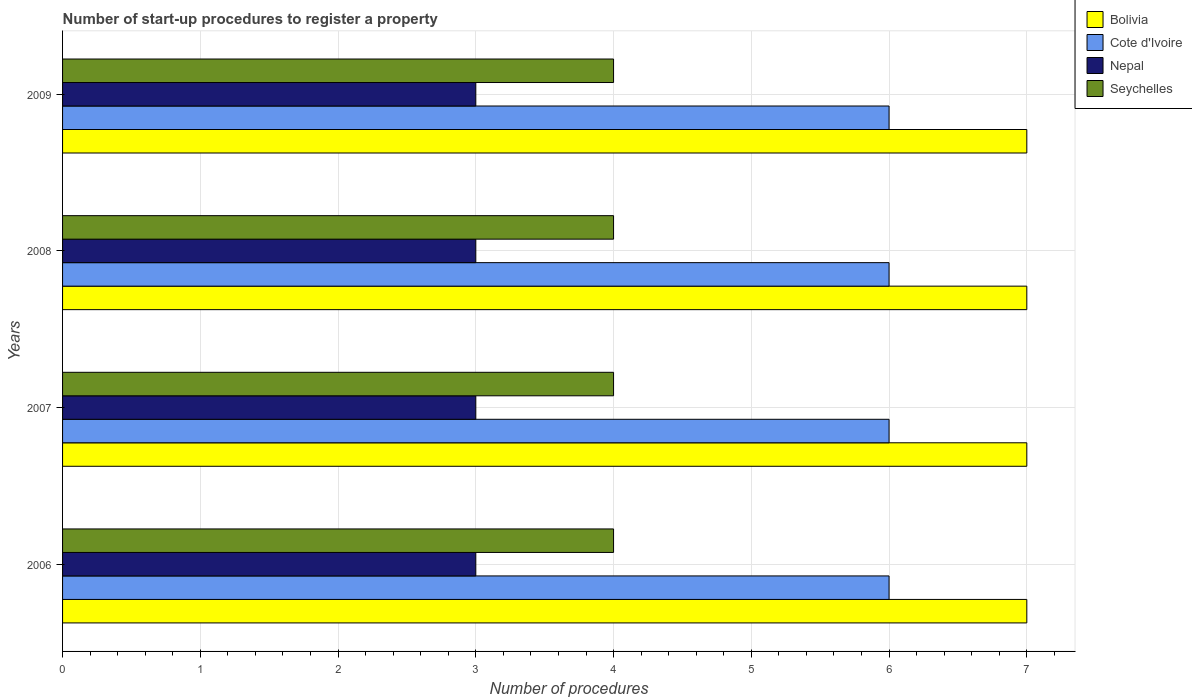How many different coloured bars are there?
Your response must be concise. 4. How many bars are there on the 1st tick from the top?
Offer a terse response. 4. How many bars are there on the 3rd tick from the bottom?
Your response must be concise. 4. In how many cases, is the number of bars for a given year not equal to the number of legend labels?
Your answer should be compact. 0. What is the number of procedures required to register a property in Nepal in 2008?
Ensure brevity in your answer.  3. Across all years, what is the maximum number of procedures required to register a property in Cote d'Ivoire?
Your answer should be very brief. 6. Across all years, what is the minimum number of procedures required to register a property in Nepal?
Your answer should be compact. 3. In which year was the number of procedures required to register a property in Seychelles minimum?
Make the answer very short. 2006. What is the total number of procedures required to register a property in Nepal in the graph?
Your answer should be very brief. 12. What is the difference between the number of procedures required to register a property in Cote d'Ivoire in 2006 and that in 2009?
Give a very brief answer. 0. What is the average number of procedures required to register a property in Cote d'Ivoire per year?
Provide a succinct answer. 6. In the year 2009, what is the difference between the number of procedures required to register a property in Cote d'Ivoire and number of procedures required to register a property in Bolivia?
Offer a very short reply. -1. What is the ratio of the number of procedures required to register a property in Seychelles in 2007 to that in 2009?
Your answer should be compact. 1. Is the number of procedures required to register a property in Seychelles in 2007 less than that in 2008?
Make the answer very short. No. In how many years, is the number of procedures required to register a property in Nepal greater than the average number of procedures required to register a property in Nepal taken over all years?
Offer a very short reply. 0. Is the sum of the number of procedures required to register a property in Nepal in 2006 and 2009 greater than the maximum number of procedures required to register a property in Seychelles across all years?
Give a very brief answer. Yes. Is it the case that in every year, the sum of the number of procedures required to register a property in Bolivia and number of procedures required to register a property in Nepal is greater than the sum of number of procedures required to register a property in Cote d'Ivoire and number of procedures required to register a property in Seychelles?
Keep it short and to the point. No. What does the 2nd bar from the top in 2006 represents?
Give a very brief answer. Nepal. What does the 2nd bar from the bottom in 2009 represents?
Keep it short and to the point. Cote d'Ivoire. Is it the case that in every year, the sum of the number of procedures required to register a property in Nepal and number of procedures required to register a property in Seychelles is greater than the number of procedures required to register a property in Cote d'Ivoire?
Provide a succinct answer. Yes. Are all the bars in the graph horizontal?
Give a very brief answer. Yes. How many years are there in the graph?
Your response must be concise. 4. Does the graph contain any zero values?
Offer a very short reply. No. How many legend labels are there?
Offer a terse response. 4. What is the title of the graph?
Your answer should be very brief. Number of start-up procedures to register a property. Does "Turkmenistan" appear as one of the legend labels in the graph?
Your response must be concise. No. What is the label or title of the X-axis?
Keep it short and to the point. Number of procedures. What is the Number of procedures in Bolivia in 2006?
Offer a very short reply. 7. What is the Number of procedures in Nepal in 2006?
Give a very brief answer. 3. What is the Number of procedures of Nepal in 2007?
Offer a very short reply. 3. What is the Number of procedures of Bolivia in 2008?
Your answer should be compact. 7. What is the Number of procedures of Seychelles in 2008?
Offer a very short reply. 4. Across all years, what is the maximum Number of procedures of Cote d'Ivoire?
Your answer should be very brief. 6. Across all years, what is the maximum Number of procedures in Nepal?
Your response must be concise. 3. Across all years, what is the maximum Number of procedures of Seychelles?
Offer a very short reply. 4. Across all years, what is the minimum Number of procedures of Nepal?
Provide a succinct answer. 3. Across all years, what is the minimum Number of procedures of Seychelles?
Your answer should be compact. 4. What is the total Number of procedures in Nepal in the graph?
Provide a succinct answer. 12. What is the difference between the Number of procedures in Bolivia in 2006 and that in 2007?
Provide a succinct answer. 0. What is the difference between the Number of procedures of Cote d'Ivoire in 2006 and that in 2007?
Your response must be concise. 0. What is the difference between the Number of procedures of Seychelles in 2006 and that in 2008?
Give a very brief answer. 0. What is the difference between the Number of procedures of Bolivia in 2006 and that in 2009?
Offer a terse response. 0. What is the difference between the Number of procedures in Cote d'Ivoire in 2007 and that in 2008?
Make the answer very short. 0. What is the difference between the Number of procedures of Nepal in 2007 and that in 2008?
Your response must be concise. 0. What is the difference between the Number of procedures in Seychelles in 2007 and that in 2008?
Give a very brief answer. 0. What is the difference between the Number of procedures in Bolivia in 2007 and that in 2009?
Your response must be concise. 0. What is the difference between the Number of procedures in Cote d'Ivoire in 2007 and that in 2009?
Make the answer very short. 0. What is the difference between the Number of procedures of Nepal in 2007 and that in 2009?
Keep it short and to the point. 0. What is the difference between the Number of procedures of Bolivia in 2008 and that in 2009?
Your answer should be compact. 0. What is the difference between the Number of procedures of Cote d'Ivoire in 2008 and that in 2009?
Provide a short and direct response. 0. What is the difference between the Number of procedures of Nepal in 2008 and that in 2009?
Ensure brevity in your answer.  0. What is the difference between the Number of procedures of Seychelles in 2008 and that in 2009?
Offer a terse response. 0. What is the difference between the Number of procedures in Bolivia in 2006 and the Number of procedures in Nepal in 2007?
Your answer should be very brief. 4. What is the difference between the Number of procedures of Cote d'Ivoire in 2006 and the Number of procedures of Nepal in 2007?
Make the answer very short. 3. What is the difference between the Number of procedures in Cote d'Ivoire in 2006 and the Number of procedures in Seychelles in 2007?
Offer a terse response. 2. What is the difference between the Number of procedures of Cote d'Ivoire in 2006 and the Number of procedures of Nepal in 2008?
Ensure brevity in your answer.  3. What is the difference between the Number of procedures of Bolivia in 2006 and the Number of procedures of Cote d'Ivoire in 2009?
Keep it short and to the point. 1. What is the difference between the Number of procedures in Bolivia in 2006 and the Number of procedures in Nepal in 2009?
Provide a succinct answer. 4. What is the difference between the Number of procedures in Bolivia in 2007 and the Number of procedures in Cote d'Ivoire in 2008?
Offer a terse response. 1. What is the difference between the Number of procedures in Bolivia in 2007 and the Number of procedures in Nepal in 2008?
Your response must be concise. 4. What is the difference between the Number of procedures in Bolivia in 2007 and the Number of procedures in Seychelles in 2008?
Keep it short and to the point. 3. What is the difference between the Number of procedures of Nepal in 2007 and the Number of procedures of Seychelles in 2008?
Provide a short and direct response. -1. What is the difference between the Number of procedures in Bolivia in 2007 and the Number of procedures in Cote d'Ivoire in 2009?
Offer a very short reply. 1. What is the difference between the Number of procedures in Bolivia in 2007 and the Number of procedures in Seychelles in 2009?
Offer a very short reply. 3. What is the difference between the Number of procedures in Bolivia in 2008 and the Number of procedures in Seychelles in 2009?
Offer a very short reply. 3. What is the difference between the Number of procedures of Cote d'Ivoire in 2008 and the Number of procedures of Nepal in 2009?
Your answer should be very brief. 3. What is the difference between the Number of procedures in Cote d'Ivoire in 2008 and the Number of procedures in Seychelles in 2009?
Ensure brevity in your answer.  2. What is the difference between the Number of procedures in Nepal in 2008 and the Number of procedures in Seychelles in 2009?
Your answer should be compact. -1. What is the average Number of procedures of Cote d'Ivoire per year?
Make the answer very short. 6. What is the average Number of procedures of Nepal per year?
Offer a very short reply. 3. In the year 2006, what is the difference between the Number of procedures in Cote d'Ivoire and Number of procedures in Nepal?
Provide a succinct answer. 3. In the year 2006, what is the difference between the Number of procedures in Nepal and Number of procedures in Seychelles?
Your answer should be compact. -1. In the year 2007, what is the difference between the Number of procedures of Bolivia and Number of procedures of Cote d'Ivoire?
Your answer should be compact. 1. In the year 2007, what is the difference between the Number of procedures in Bolivia and Number of procedures in Nepal?
Offer a very short reply. 4. In the year 2007, what is the difference between the Number of procedures of Cote d'Ivoire and Number of procedures of Nepal?
Keep it short and to the point. 3. In the year 2007, what is the difference between the Number of procedures in Cote d'Ivoire and Number of procedures in Seychelles?
Provide a succinct answer. 2. In the year 2008, what is the difference between the Number of procedures of Bolivia and Number of procedures of Nepal?
Give a very brief answer. 4. In the year 2008, what is the difference between the Number of procedures in Bolivia and Number of procedures in Seychelles?
Offer a very short reply. 3. In the year 2008, what is the difference between the Number of procedures of Cote d'Ivoire and Number of procedures of Seychelles?
Your response must be concise. 2. In the year 2009, what is the difference between the Number of procedures of Bolivia and Number of procedures of Seychelles?
Your response must be concise. 3. In the year 2009, what is the difference between the Number of procedures of Nepal and Number of procedures of Seychelles?
Offer a terse response. -1. What is the ratio of the Number of procedures in Cote d'Ivoire in 2006 to that in 2009?
Offer a terse response. 1. What is the ratio of the Number of procedures of Seychelles in 2006 to that in 2009?
Keep it short and to the point. 1. What is the ratio of the Number of procedures in Nepal in 2007 to that in 2008?
Make the answer very short. 1. What is the ratio of the Number of procedures in Seychelles in 2007 to that in 2008?
Provide a short and direct response. 1. What is the ratio of the Number of procedures in Nepal in 2007 to that in 2009?
Give a very brief answer. 1. What is the difference between the highest and the second highest Number of procedures of Cote d'Ivoire?
Give a very brief answer. 0. What is the difference between the highest and the second highest Number of procedures of Seychelles?
Offer a very short reply. 0. What is the difference between the highest and the lowest Number of procedures in Bolivia?
Give a very brief answer. 0. What is the difference between the highest and the lowest Number of procedures of Nepal?
Ensure brevity in your answer.  0. 